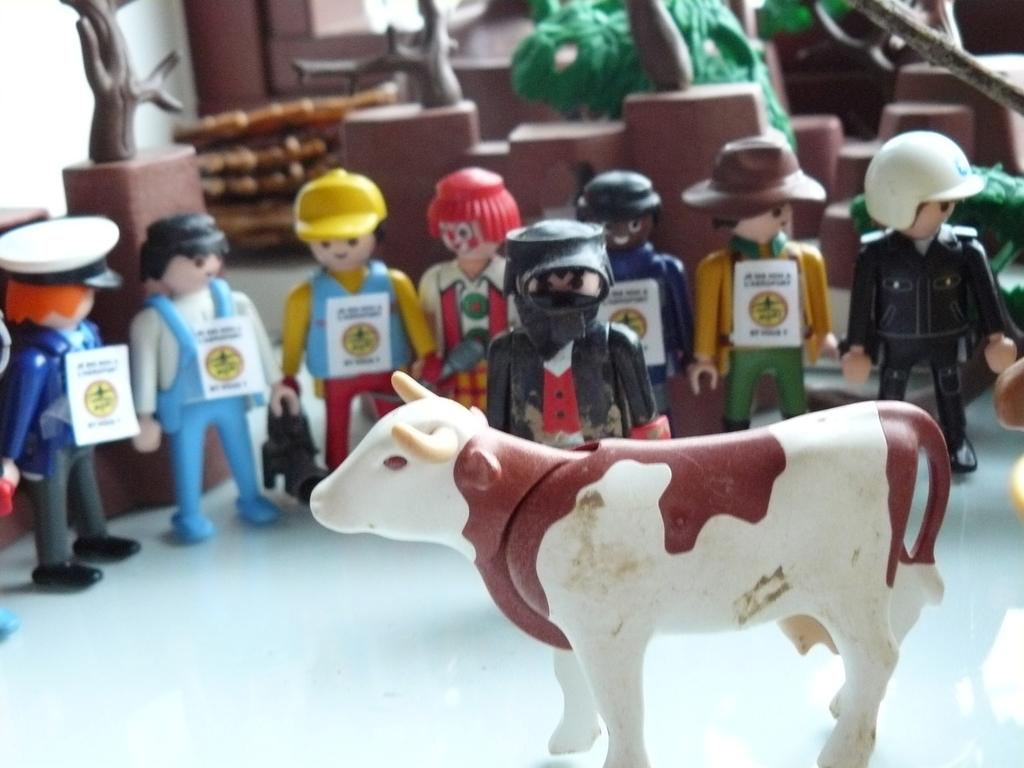What type of objects can be seen in the image? There are toys in the image. What animal is present in the image? There is a cow in the image. Are there any human figures in the image? Yes, there are people standing in the image. What type of natural elements can be seen in the image? There are branches and a tree in the image. Can you read the letters on the cow's back in the image? There are no letters present on the cow's back in the image. How many ducks are visible in the image? There are no ducks present in the image. 